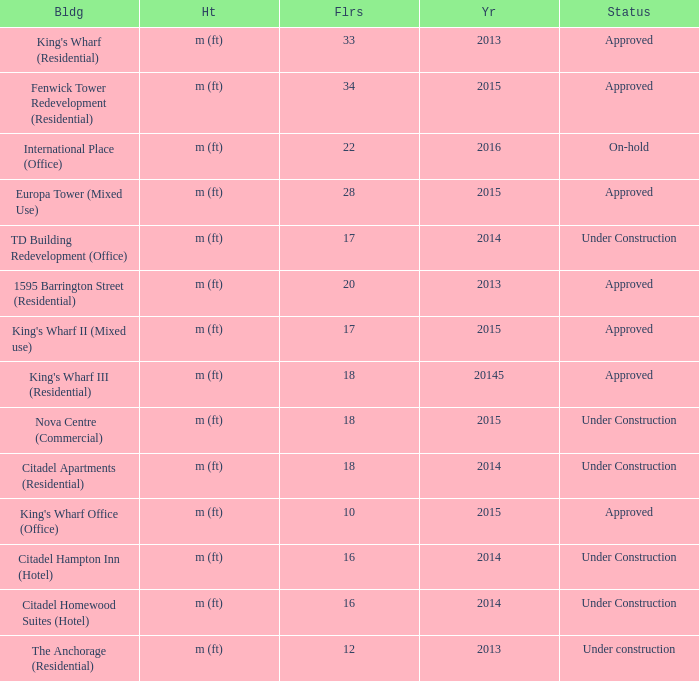What are the number of floors for the building of td building redevelopment (office)? 17.0. 